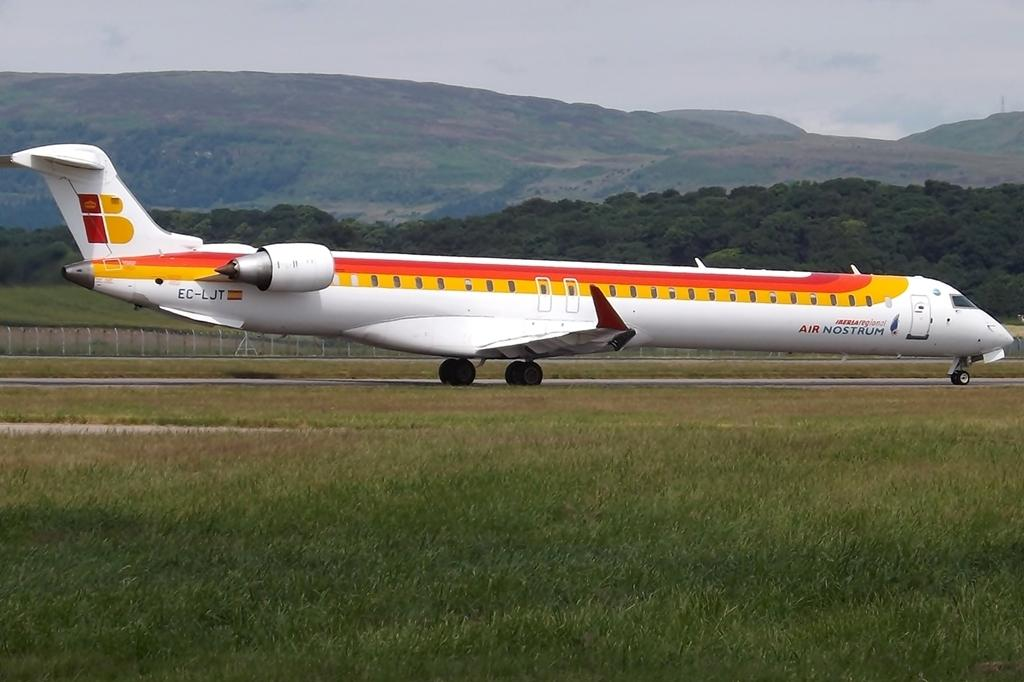<image>
Provide a brief description of the given image. An Air Nostrum airplane with the lettes EC-LJT on the tail. 